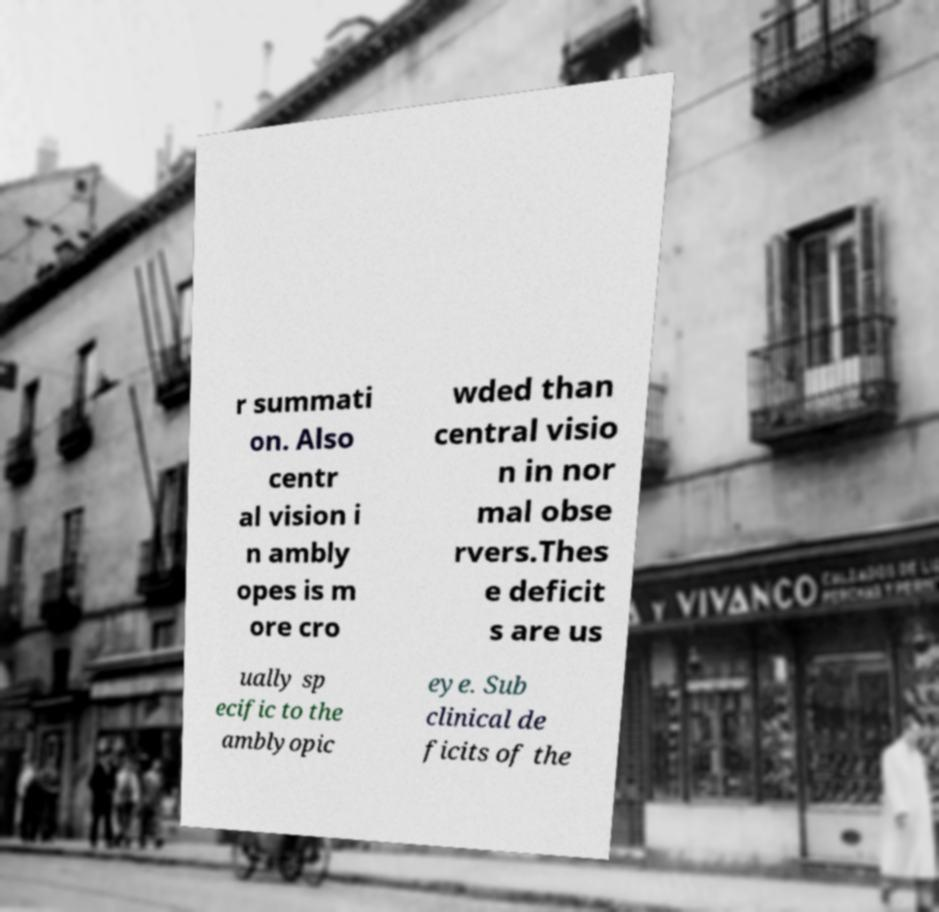Can you read and provide the text displayed in the image?This photo seems to have some interesting text. Can you extract and type it out for me? r summati on. Also centr al vision i n ambly opes is m ore cro wded than central visio n in nor mal obse rvers.Thes e deficit s are us ually sp ecific to the amblyopic eye. Sub clinical de ficits of the 